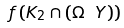Convert formula to latex. <formula><loc_0><loc_0><loc_500><loc_500>f \left ( K _ { 2 } \cap ( \Omega \ Y ) \right )</formula> 